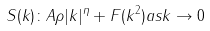Convert formula to latex. <formula><loc_0><loc_0><loc_500><loc_500>S ( k ) \colon A \rho | k | ^ { \eta } + F ( k ^ { 2 } ) { a s } k \rightarrow 0</formula> 